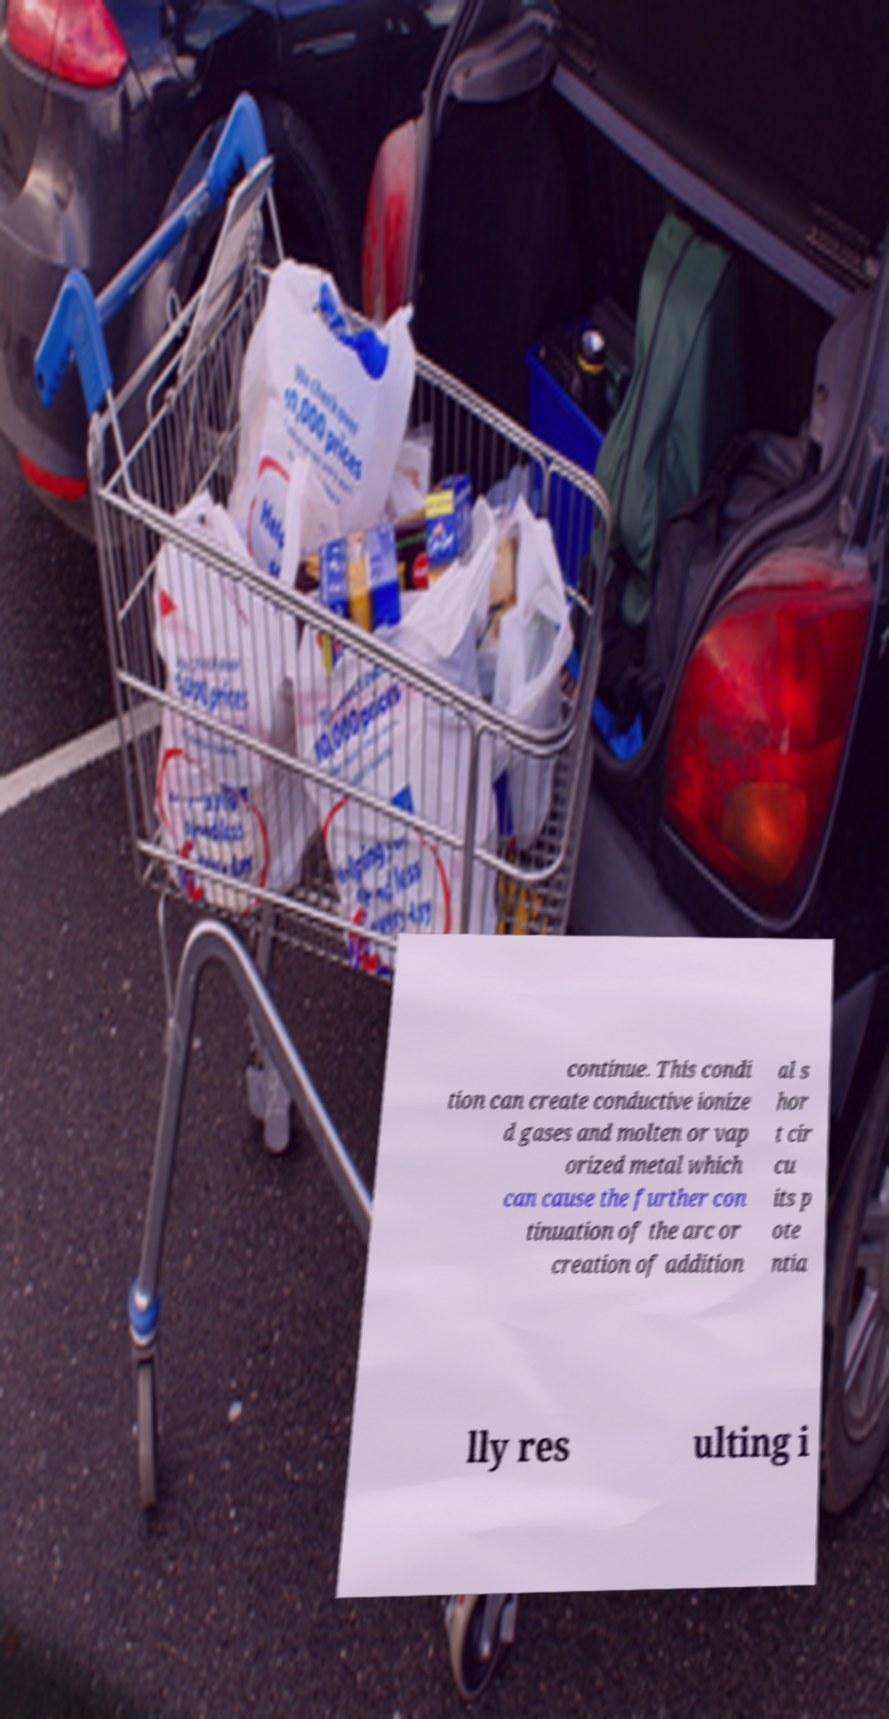Could you extract and type out the text from this image? continue. This condi tion can create conductive ionize d gases and molten or vap orized metal which can cause the further con tinuation of the arc or creation of addition al s hor t cir cu its p ote ntia lly res ulting i 